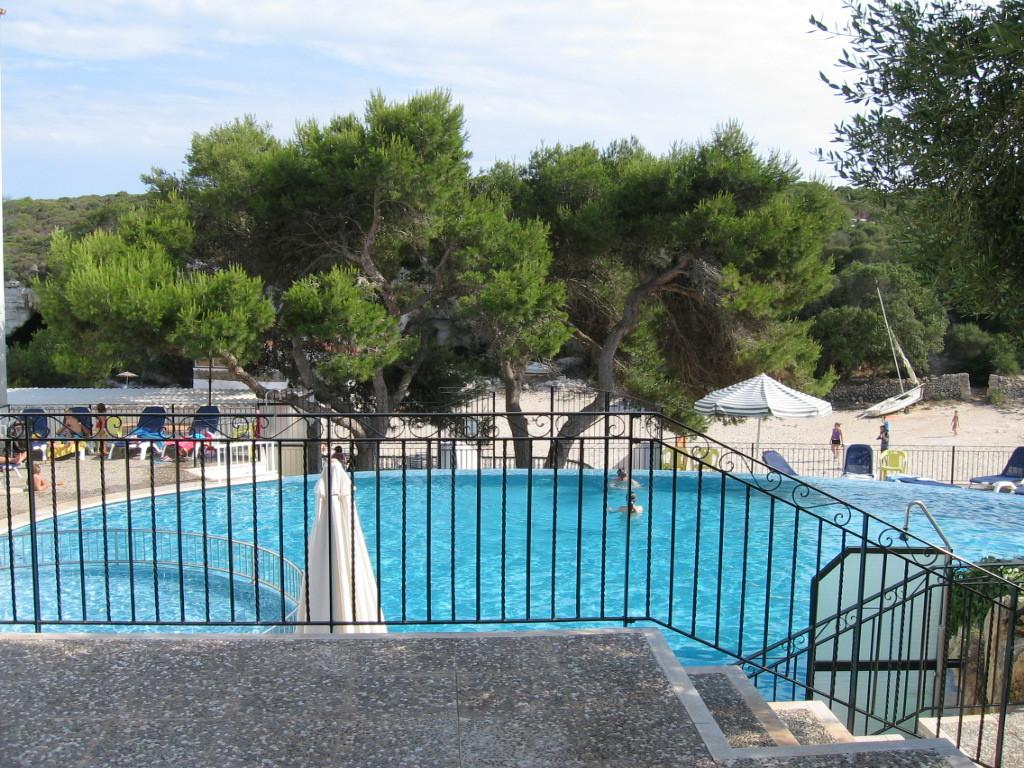What type of structure can be seen in the image? There are steps and a fence in the image. What type of vegetation is present in the image? There are trees in the image. What type of seating is available in the image? There are chairs in the image. What type of shelter is present in the image? There is an umbrella in the image. What are the two persons in the image doing? The two persons are in water in the image. What can be seen in the background of the image? The sky with clouds is visible in the background of the image. What type of flower is being used as a drink in the image? There is no flower or drink present in the image. What type of agreement is being signed by the two persons in the water? There is no agreement being signed in the image; the two persons are simply in water. 